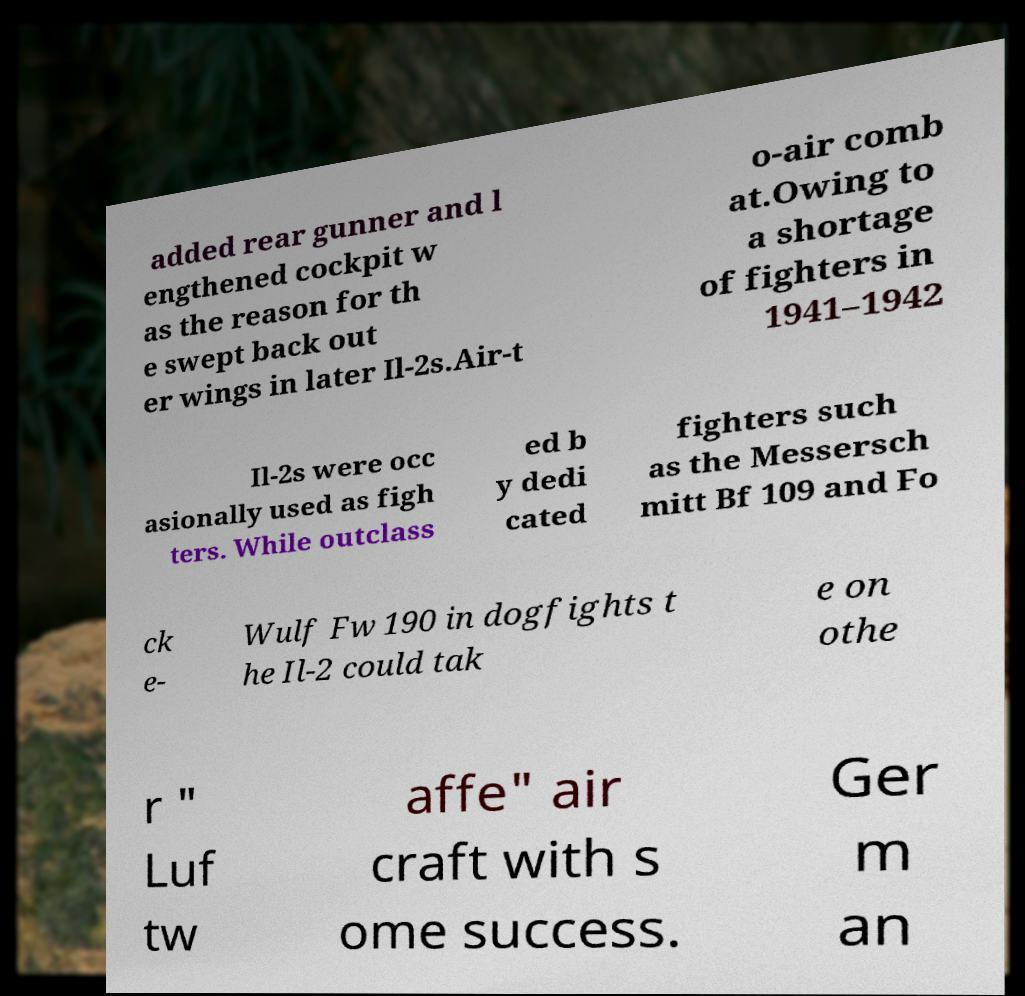Could you extract and type out the text from this image? added rear gunner and l engthened cockpit w as the reason for th e swept back out er wings in later Il-2s.Air-t o-air comb at.Owing to a shortage of fighters in 1941–1942 Il-2s were occ asionally used as figh ters. While outclass ed b y dedi cated fighters such as the Messersch mitt Bf 109 and Fo ck e- Wulf Fw 190 in dogfights t he Il-2 could tak e on othe r " Luf tw affe" air craft with s ome success. Ger m an 